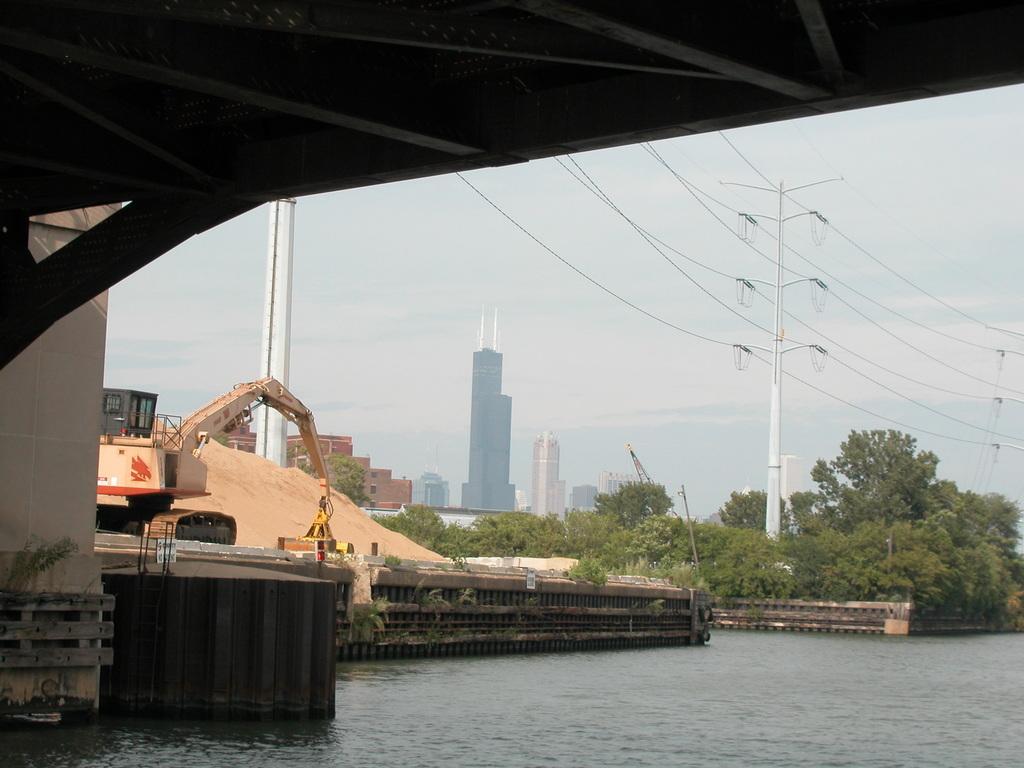Could you give a brief overview of what you see in this image? In this image there is water at the bottom. On the left side there is a bridge above the water. On the right side there are electric poles to which there are wires. In the background there are buildings and trees. On the left side there is a crane working near the sand. 